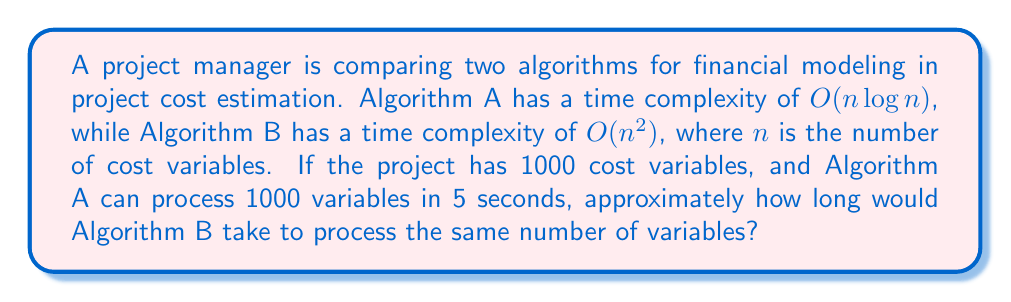Could you help me with this problem? To solve this problem, we need to follow these steps:

1. Understand the given information:
   - Algorithm A: $O(n \log n)$
   - Algorithm B: $O(n^2)$
   - $n = 1000$ (number of cost variables)
   - Algorithm A takes 5 seconds for 1000 variables

2. Calculate the ratio of time complexities:
   $$\frac{\text{Time complexity of B}}{\text{Time complexity of A}} = \frac{n^2}{n \log n} = \frac{n}{\log n}$$

3. For $n = 1000$:
   $$\frac{1000}{\log 1000} \approx \frac{1000}{6.91} \approx 144.72$$

4. This ratio indicates that Algorithm B is approximately 144.72 times slower than Algorithm A for $n = 1000$.

5. Calculate the estimated time for Algorithm B:
   $$\text{Time for B} = 5 \text{ seconds} \times 144.72 \approx 723.6 \text{ seconds}$$

6. Convert to minutes:
   $$723.6 \text{ seconds} \div 60 \text{ seconds/minute} \approx 12.06 \text{ minutes}$$

Therefore, Algorithm B would take approximately 12 minutes to process 1000 cost variables.
Answer: Approximately 12 minutes 